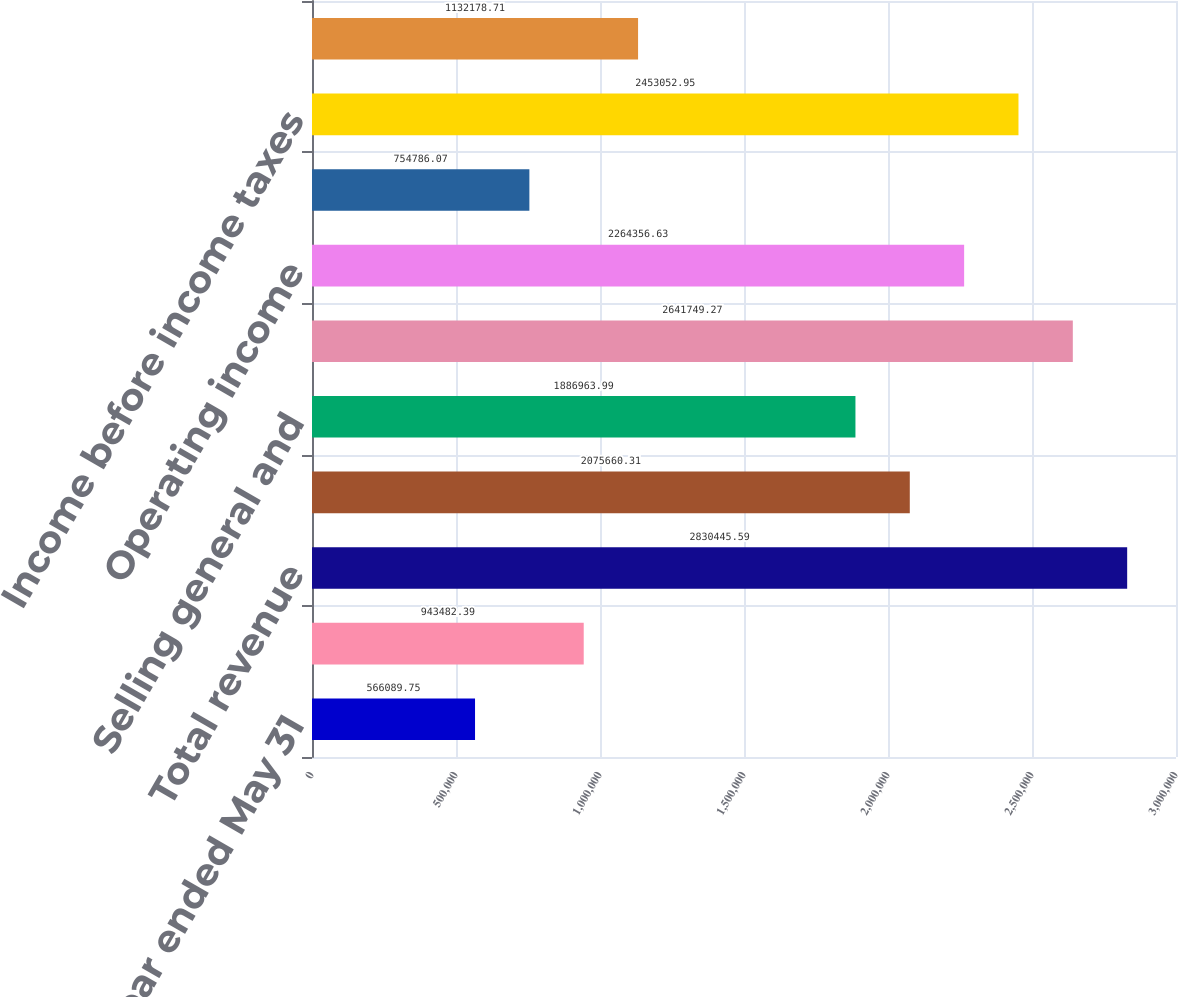Convert chart. <chart><loc_0><loc_0><loc_500><loc_500><bar_chart><fcel>Year ended May 31<fcel>Interest on funds held for<fcel>Total revenue<fcel>Operating expenses<fcel>Selling general and<fcel>Total expenses<fcel>Operating income<fcel>Investment income net<fcel>Income before income taxes<fcel>Income taxes<nl><fcel>566090<fcel>943482<fcel>2.83045e+06<fcel>2.07566e+06<fcel>1.88696e+06<fcel>2.64175e+06<fcel>2.26436e+06<fcel>754786<fcel>2.45305e+06<fcel>1.13218e+06<nl></chart> 